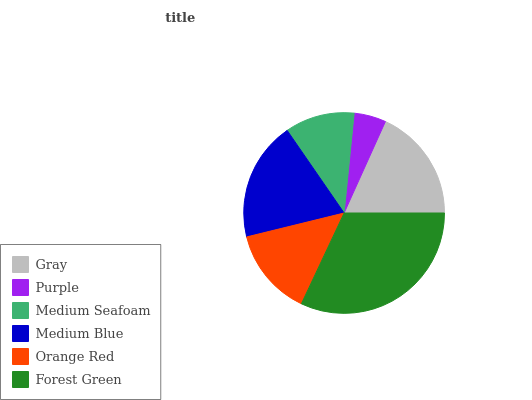Is Purple the minimum?
Answer yes or no. Yes. Is Forest Green the maximum?
Answer yes or no. Yes. Is Medium Seafoam the minimum?
Answer yes or no. No. Is Medium Seafoam the maximum?
Answer yes or no. No. Is Medium Seafoam greater than Purple?
Answer yes or no. Yes. Is Purple less than Medium Seafoam?
Answer yes or no. Yes. Is Purple greater than Medium Seafoam?
Answer yes or no. No. Is Medium Seafoam less than Purple?
Answer yes or no. No. Is Gray the high median?
Answer yes or no. Yes. Is Orange Red the low median?
Answer yes or no. Yes. Is Forest Green the high median?
Answer yes or no. No. Is Medium Blue the low median?
Answer yes or no. No. 